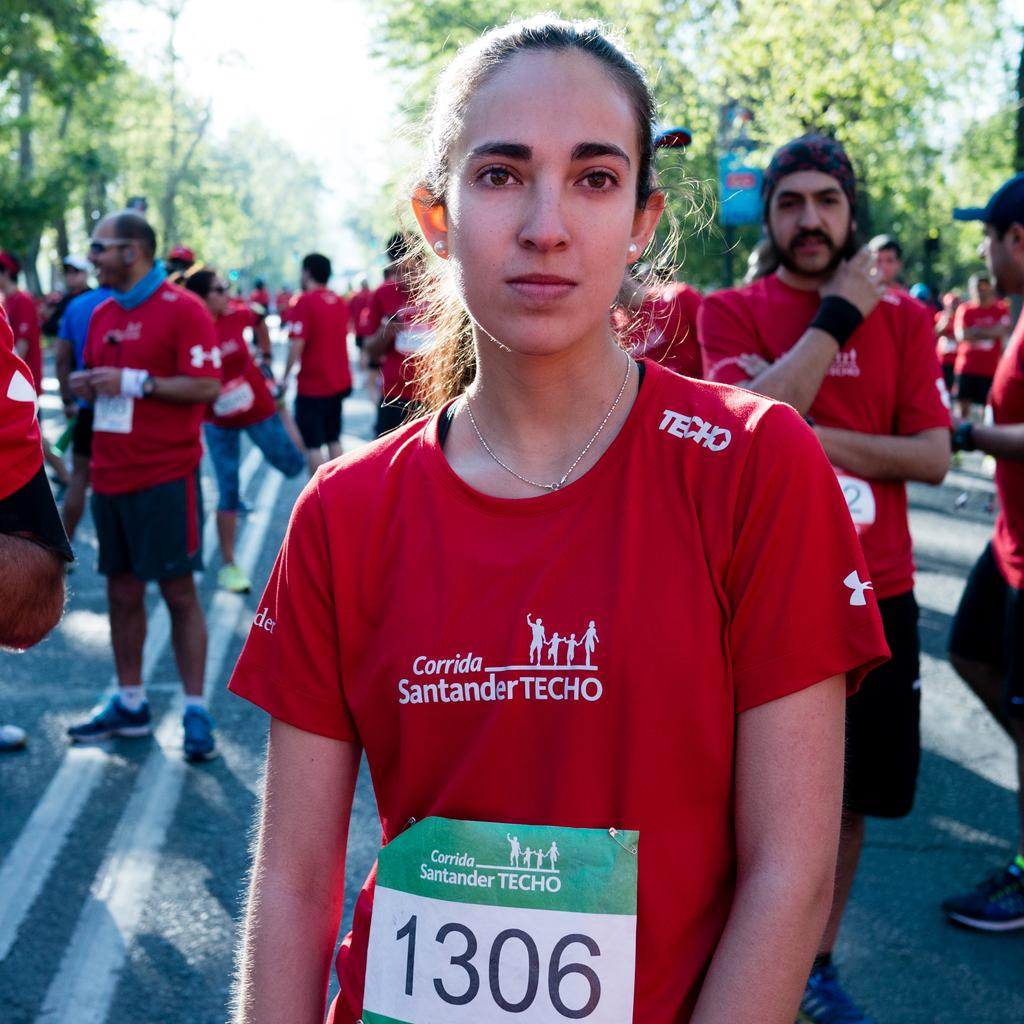Who is the main subject in the foreground of the image? There is a lady in the foreground of the image. What is the lady wearing in the image? The lady is wearing a red color T-shirt. What can be seen in the background of the image? There are people on the road and trees in the background of the image. How many screws can be seen on the lady's red T-shirt in the image? There are no screws visible on the lady's red T-shirt in the image. What type of apples are being sold by the people on the road in the image? There is no mention of apples or any type of fruit being sold by the people on the road in the image. 